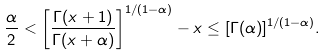Convert formula to latex. <formula><loc_0><loc_0><loc_500><loc_500>\frac { \alpha } 2 < \left [ \frac { \Gamma ( x + 1 ) } { \Gamma ( x + \alpha ) } \right ] ^ { 1 / ( 1 - \alpha ) } - x \leq [ \Gamma ( \alpha ) ] ^ { 1 / ( 1 - \alpha ) } .</formula> 